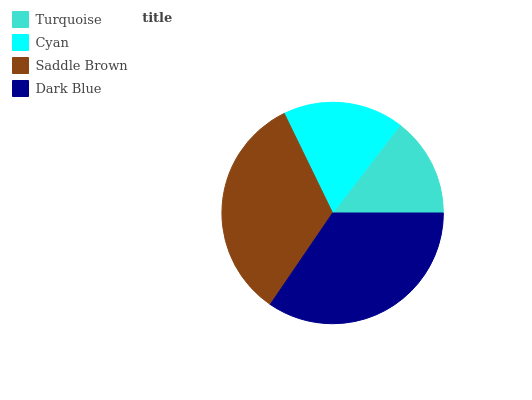Is Turquoise the minimum?
Answer yes or no. Yes. Is Dark Blue the maximum?
Answer yes or no. Yes. Is Cyan the minimum?
Answer yes or no. No. Is Cyan the maximum?
Answer yes or no. No. Is Cyan greater than Turquoise?
Answer yes or no. Yes. Is Turquoise less than Cyan?
Answer yes or no. Yes. Is Turquoise greater than Cyan?
Answer yes or no. No. Is Cyan less than Turquoise?
Answer yes or no. No. Is Saddle Brown the high median?
Answer yes or no. Yes. Is Cyan the low median?
Answer yes or no. Yes. Is Cyan the high median?
Answer yes or no. No. Is Saddle Brown the low median?
Answer yes or no. No. 